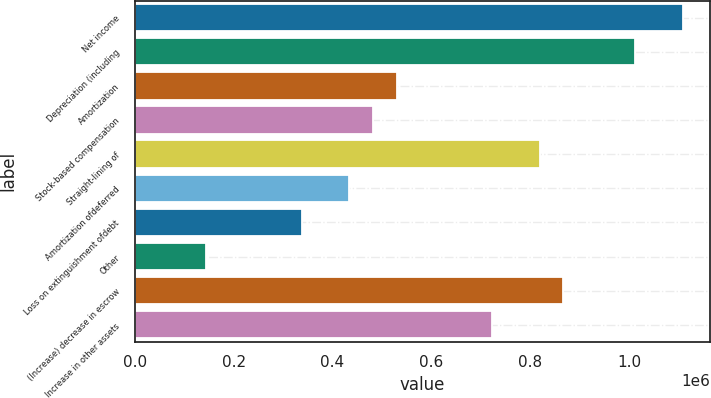Convert chart. <chart><loc_0><loc_0><loc_500><loc_500><bar_chart><fcel>Net income<fcel>Depreciation (including<fcel>Amortization<fcel>Stock-based compensation<fcel>Straight-lining of<fcel>Amortization ofdeferred<fcel>Loss on extinguishment ofdebt<fcel>Other<fcel>(Increase) decrease in escrow<fcel>Increase in other assets<nl><fcel>1.10809e+06<fcel>1.01176e+06<fcel>530136<fcel>481974<fcel>819111<fcel>433812<fcel>337487<fcel>144837<fcel>867273<fcel>722786<nl></chart> 